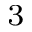<formula> <loc_0><loc_0><loc_500><loc_500>_ { 3 }</formula> 